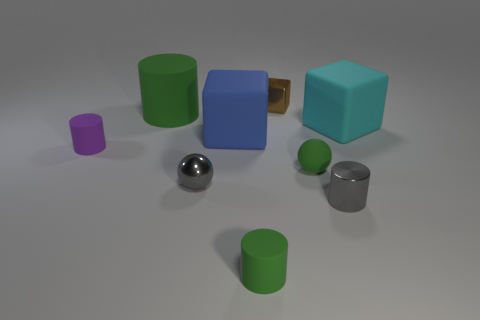There is a sphere that is the same color as the metal cylinder; what is its size?
Offer a terse response. Small. There is a shiny cylinder; is it the same color as the small rubber object behind the small green matte ball?
Your answer should be very brief. No. Are there fewer large green metallic cylinders than rubber cubes?
Your answer should be compact. Yes. There is a cylinder behind the big cyan thing; does it have the same color as the metallic sphere?
Make the answer very short. No. How many cyan cubes are the same size as the blue block?
Make the answer very short. 1. Are there any large things that have the same color as the big cylinder?
Give a very brief answer. No. Is the material of the large cylinder the same as the big blue thing?
Provide a succinct answer. Yes. What number of tiny green rubber things are the same shape as the big blue matte thing?
Your answer should be very brief. 0. There is a big blue object that is the same material as the big cyan cube; what shape is it?
Provide a succinct answer. Cube. The tiny shiny thing behind the green cylinder that is behind the purple thing is what color?
Make the answer very short. Brown. 